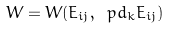Convert formula to latex. <formula><loc_0><loc_0><loc_500><loc_500>W = W ( E _ { i j } , \ p d _ { k } E _ { i j } )</formula> 